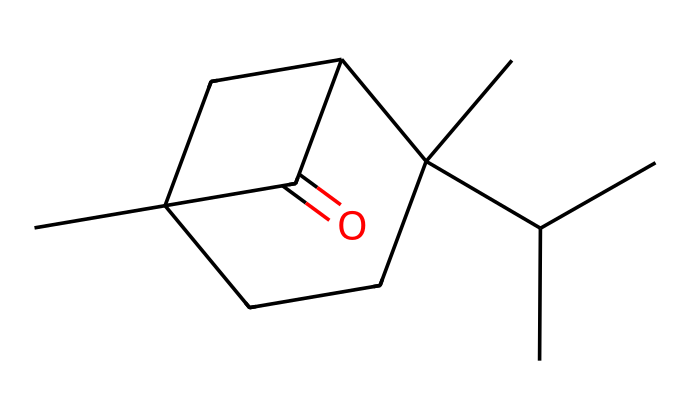How many carbon atoms are in camphor? To determine the number of carbon atoms, count the number of 'C' symbols in the SMILES representation. There are 10 'C' symbols.
Answer: 10 What is the degree of saturation in camphor? The structure contains one carbonyl group (C=O) and no additional ring structures or multiple bonds outside of this, which indicates a single degree of saturation.
Answer: 1 Identify the functional group present in camphor. The presence of the carbonyl group (C=O) in the SMILES indicates that camphor is categorized as a ketone.
Answer: ketone Which part of the structure indicates camphor's ketone nature? The C=O bond in the structure is indicative of the ketone functional group; specifically, it shows the carbon atom is double-bonded to oxygen.
Answer: C=O How many hydrogen atoms are bonded to the carbon skeleton of camphor? By examining the structure, each carbon atom ideally bonds to four atoms total; thus, calculate the hydrogen as needed, considering the valence requirements and the presence of the carbonyl. There are 14 hydrogen atoms in total.
Answer: 14 What is the molecular formula of camphor based on its structure? Derived from counting the carbon (C), hydrogen (H), and oxygen (O) based on the structure, the molecular formula for camphor is C10H16O.
Answer: C10H16O 